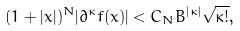<formula> <loc_0><loc_0><loc_500><loc_500>( 1 + | x | ) ^ { N } | \partial ^ { \kappa } f ( x ) | < C _ { N } B ^ { | \kappa | } \sqrt { \kappa ! } ,</formula> 